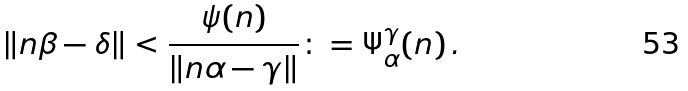<formula> <loc_0><loc_0><loc_500><loc_500>\| n \beta - \delta \| < \frac { \psi ( n ) } { \| n \alpha - \gamma \| } \colon = \Psi ^ { \gamma } _ { \alpha } ( n ) \, .</formula> 